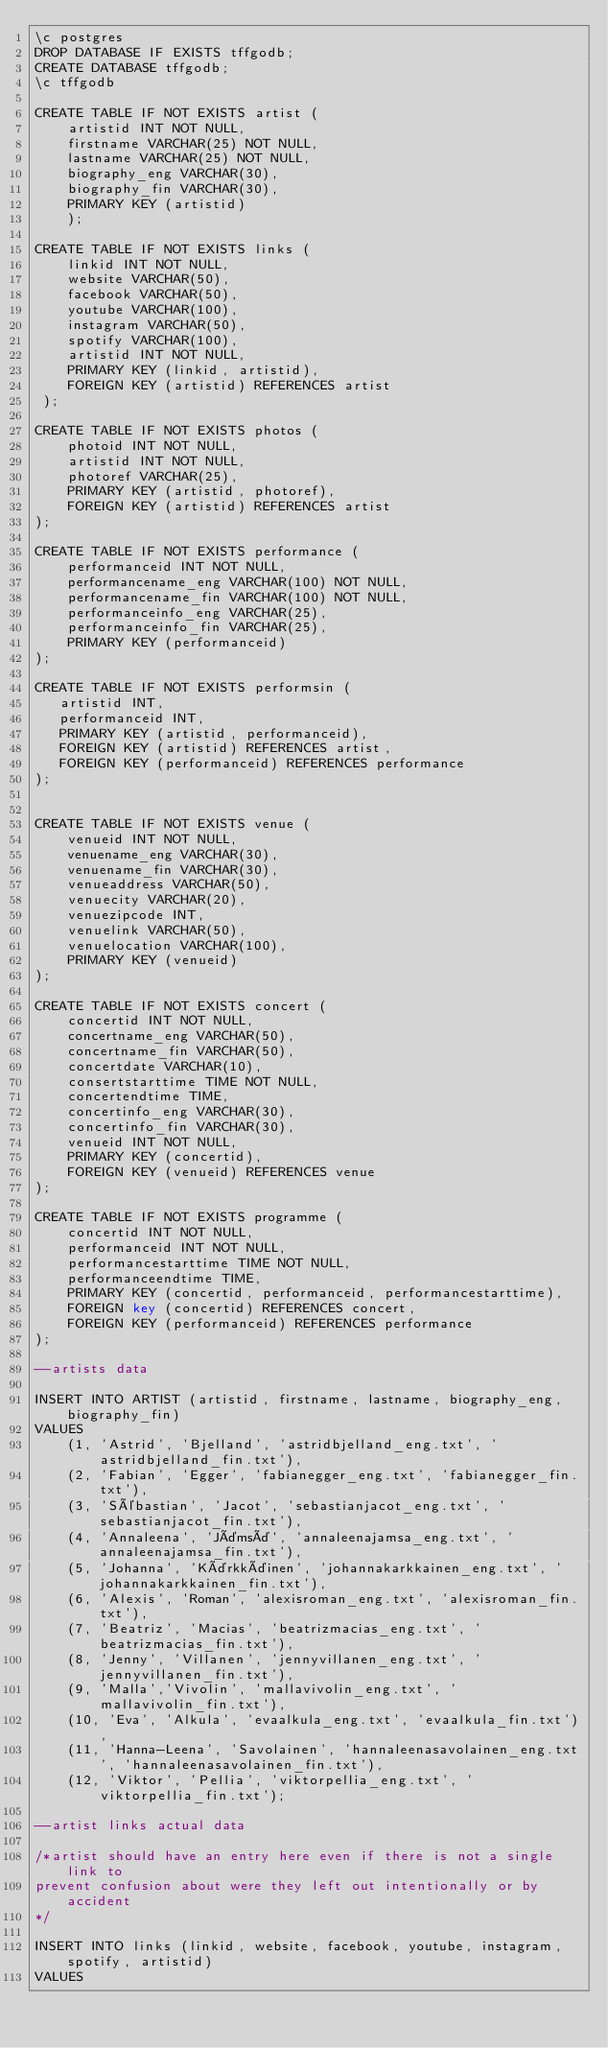<code> <loc_0><loc_0><loc_500><loc_500><_SQL_>\c postgres
DROP DATABASE IF EXISTS tffgodb;
CREATE DATABASE tffgodb;
\c tffgodb

CREATE TABLE IF NOT EXISTS artist (
    artistid INT NOT NULL,
    firstname VARCHAR(25) NOT NULL,
    lastname VARCHAR(25) NOT NULL,
    biography_eng VARCHAR(30),
    biography_fin VARCHAR(30),
    PRIMARY KEY (artistid)
    );

CREATE TABLE IF NOT EXISTS links (
    linkid INT NOT NULL,
    website VARCHAR(50),
    facebook VARCHAR(50),
    youtube VARCHAR(100),
    instagram VARCHAR(50),
    spotify VARCHAR(100),
    artistid INT NOT NULL,
    PRIMARY KEY (linkid, artistid),
    FOREIGN KEY (artistid) REFERENCES artist
 );

CREATE TABLE IF NOT EXISTS photos (
    photoid INT NOT NULL,
    artistid INT NOT NULL,
    photoref VARCHAR(25),
    PRIMARY KEY (artistid, photoref),
    FOREIGN KEY (artistid) REFERENCES artist
);

CREATE TABLE IF NOT EXISTS performance (
    performanceid INT NOT NULL,
    performancename_eng VARCHAR(100) NOT NULL,
    performancename_fin VARCHAR(100) NOT NULL,
    performanceinfo_eng VARCHAR(25),
    performanceinfo_fin VARCHAR(25),
    PRIMARY KEY (performanceid)
);

CREATE TABLE IF NOT EXISTS performsin (
   artistid INT,
   performanceid INT,
   PRIMARY KEY (artistid, performanceid),
   FOREIGN KEY (artistid) REFERENCES artist,
   FOREIGN KEY (performanceid) REFERENCES performance
);


CREATE TABLE IF NOT EXISTS venue (
    venueid INT NOT NULL,
    venuename_eng VARCHAR(30),
    venuename_fin VARCHAR(30),
    venueaddress VARCHAR(50),
    venuecity VARCHAR(20),
    venuezipcode INT,
    venuelink VARCHAR(50),
    venuelocation VARCHAR(100),
    PRIMARY KEY (venueid)
);

CREATE TABLE IF NOT EXISTS concert (
    concertid INT NOT NULL,
    concertname_eng VARCHAR(50),
    concertname_fin VARCHAR(50),
    concertdate VARCHAR(10),
    consertstarttime TIME NOT NULL,
    concertendtime TIME,
    concertinfo_eng VARCHAR(30),
    concertinfo_fin VARCHAR(30),
    venueid INT NOT NULL,
    PRIMARY KEY (concertid),
    FOREIGN KEY (venueid) REFERENCES venue
);

CREATE TABLE IF NOT EXISTS programme (
    concertid INT NOT NULL,
    performanceid INT NOT NULL,
    performancestarttime TIME NOT NULL,
    performanceendtime TIME,
    PRIMARY KEY (concertid, performanceid, performancestarttime),
    FOREIGN key (concertid) REFERENCES concert,
    FOREIGN KEY (performanceid) REFERENCES performance
);

--artists data

INSERT INTO ARTIST (artistid, firstname, lastname, biography_eng, biography_fin) 
VALUES 
    (1, 'Astrid', 'Bjelland', 'astridbjelland_eng.txt', 'astridbjelland_fin.txt'),
    (2, 'Fabian', 'Egger', 'fabianegger_eng.txt', 'fabianegger_fin.txt'),
    (3, 'Sébastian', 'Jacot', 'sebastianjacot_eng.txt', 'sebastianjacot_fin.txt'),
    (4, 'Annaleena', 'Jämsä', 'annaleenajamsa_eng.txt', 'annaleenajamsa_fin.txt'),
    (5, 'Johanna', 'Kärkkäinen', 'johannakarkkainen_eng.txt', 'johannakarkkainen_fin.txt'),
    (6, 'Alexis', 'Roman', 'alexisroman_eng.txt', 'alexisroman_fin.txt'),
    (7, 'Beatriz', 'Macias', 'beatrizmacias_eng.txt', 'beatrizmacias_fin.txt'),
    (8, 'Jenny', 'Villanen', 'jennyvillanen_eng.txt', 'jennyvillanen_fin.txt'),
    (9, 'Malla','Vivolin', 'mallavivolin_eng.txt', 'mallavivolin_fin.txt'),
    (10, 'Eva', 'Alkula', 'evaalkula_eng.txt', 'evaalkula_fin.txt'),
    (11, 'Hanna-Leena', 'Savolainen', 'hannaleenasavolainen_eng.txt', 'hannaleenasavolainen_fin.txt'),
    (12, 'Viktor', 'Pellia', 'viktorpellia_eng.txt', 'viktorpellia_fin.txt');

--artist links actual data

/*artist should have an entry here even if there is not a single link to 
prevent confusion about were they left out intentionally or by accident
*/

INSERT INTO links (linkid, website, facebook, youtube, instagram, spotify, artistid)
VALUES</code> 